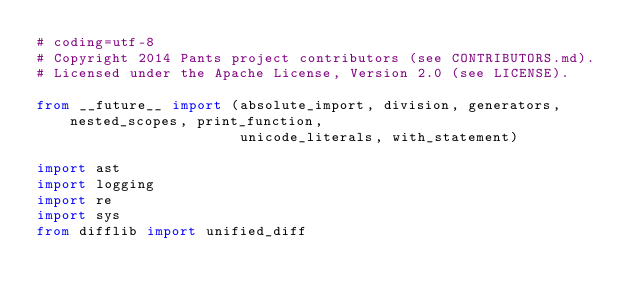Convert code to text. <code><loc_0><loc_0><loc_500><loc_500><_Python_># coding=utf-8
# Copyright 2014 Pants project contributors (see CONTRIBUTORS.md).
# Licensed under the Apache License, Version 2.0 (see LICENSE).

from __future__ import (absolute_import, division, generators, nested_scopes, print_function,
                        unicode_literals, with_statement)

import ast
import logging
import re
import sys
from difflib import unified_diff
</code> 